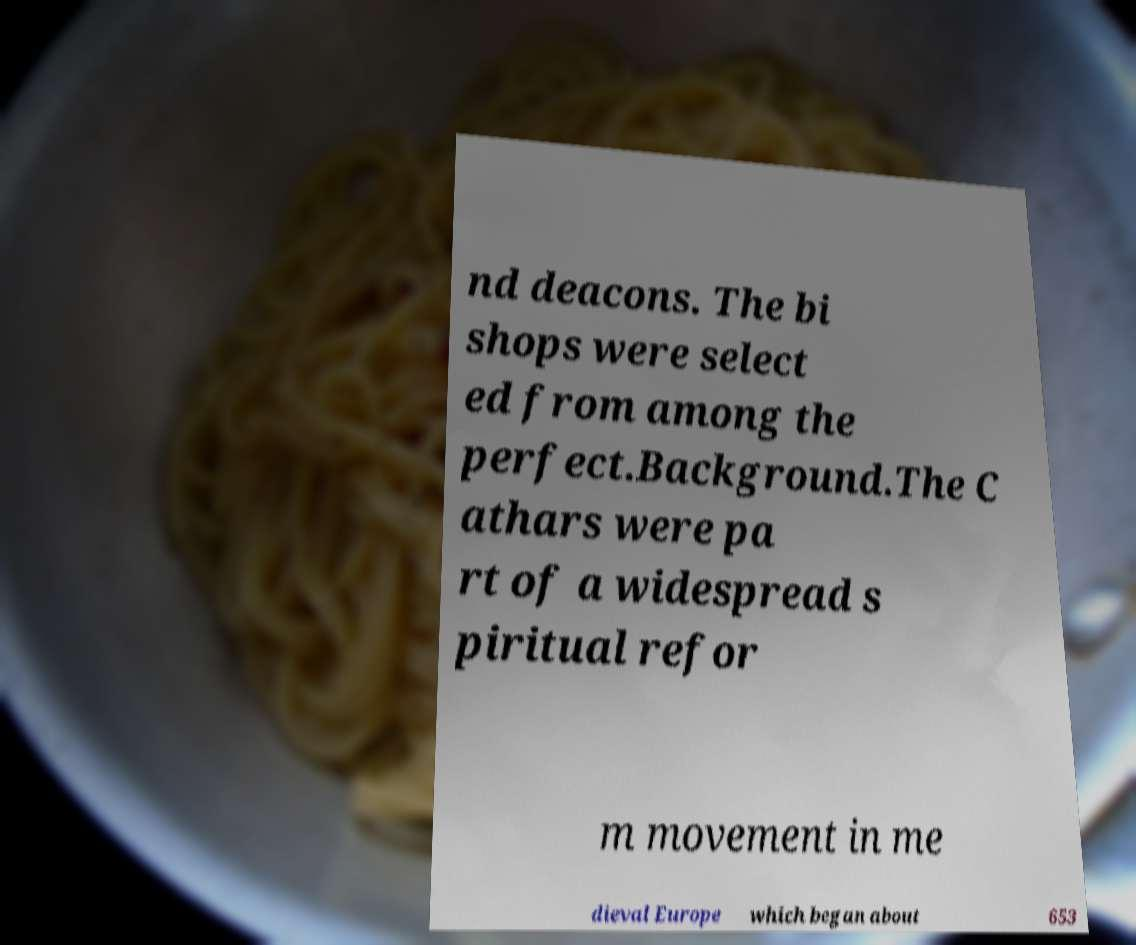Could you extract and type out the text from this image? nd deacons. The bi shops were select ed from among the perfect.Background.The C athars were pa rt of a widespread s piritual refor m movement in me dieval Europe which began about 653 